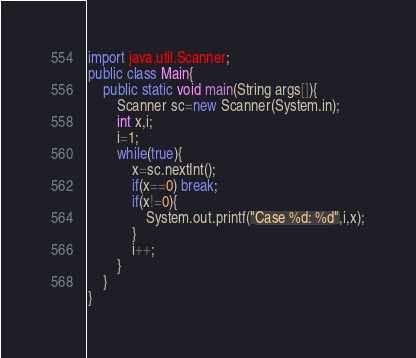<code> <loc_0><loc_0><loc_500><loc_500><_Java_>import java.util.Scanner;
public class Main{
    public static void main(String args[]){
        Scanner sc=new Scanner(System.in);
        int x,i;
        i=1;
        while(true){
            x=sc.nextInt();
            if(x==0) break;
            if(x!=0){
                System.out.printf("Case %d: %d",i,x);
            }
            i++;
        }
    }
}
</code> 